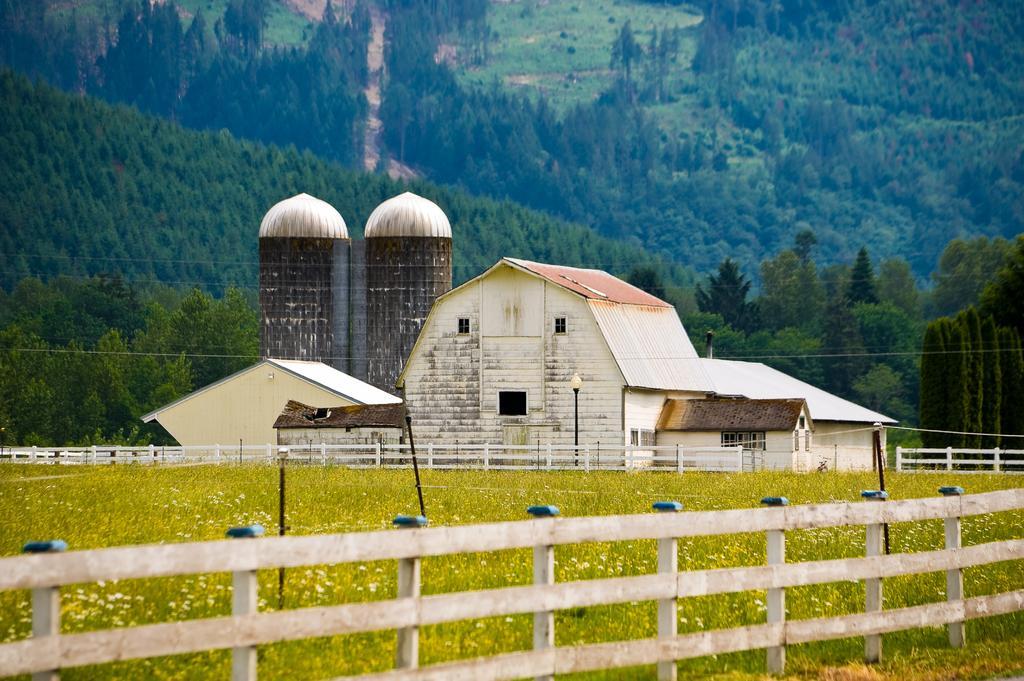Can you describe this image briefly? In this image, this looks like a factory. I think this is the small house with the windows. I can see the wooden fence. These are the plants with the flowers. I can see the trees. This looks like a mountain. 